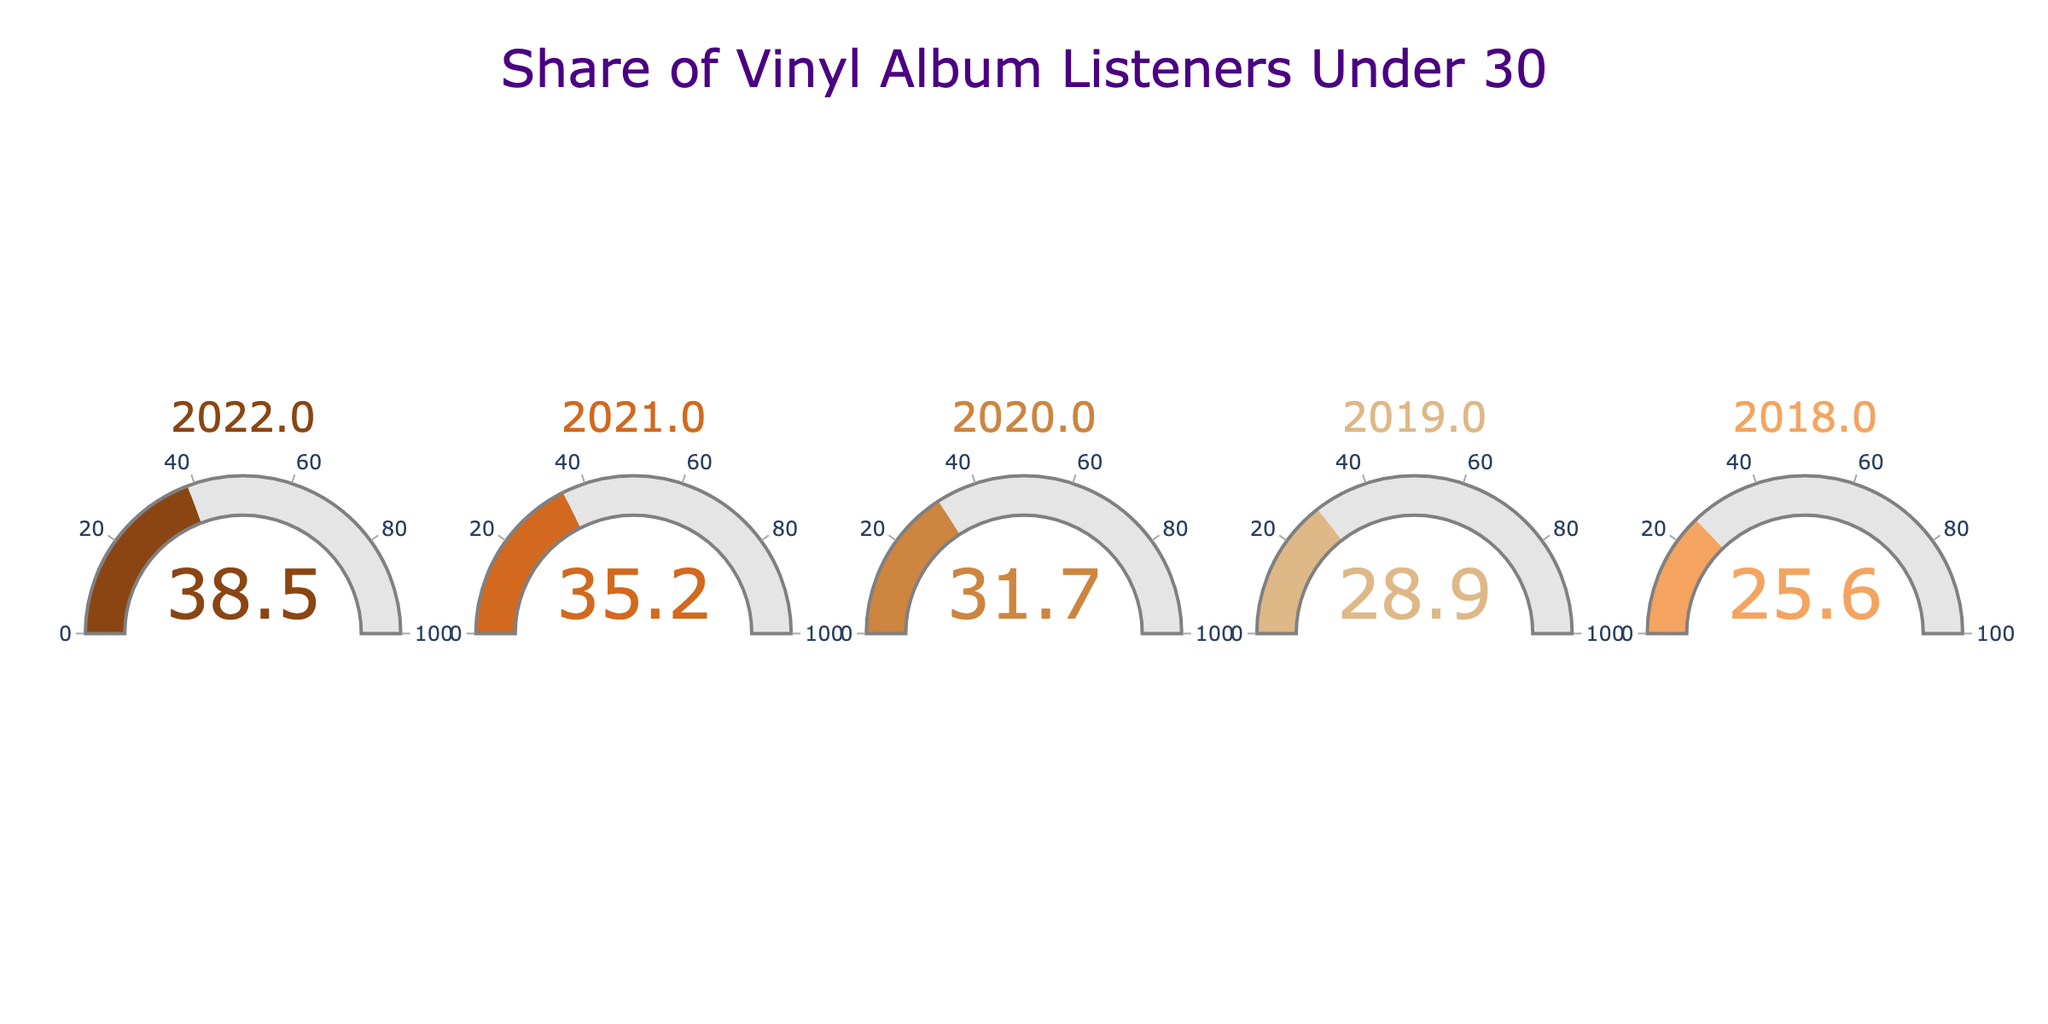What is the share of vinyl album listeners under 30 years old in 2022? The gauge chart for the year 2022 indicates a value close to 38.5%, which represents the share of vinyl album listeners under 30 years old in 2022.
Answer: 38.5% What is the overall trend in the share of vinyl album listeners under 30 years old from 2018 to 2022? Observing the values from the gauge charts for each year, there is a clear increasing trend in the share of vinyl album listeners under 30 years old, starting from 25.6% in 2018 and reaching 38.5% in 2022.
Answer: Increasing Which year shows the largest increase in the share of vinyl album listeners under 30 years old compared to the previous year? By comparing the year-over-year increases: 2019-2018 (28.9%-25.6%=3.3%), 2020-2019 (31.7%-28.9%=2.8%), 2021-2020 (35.2%-31.7%=3.5%), and 2022-2021 (38.5%-35.2%=3.3%), the largest increase is seen in 2021 compared to 2020 with an increase of 3.5%.
Answer: 2021 What is the average share of vinyl listeners under 30 years old over the five years displayed? To find the average, sum the values for each year (25.6 + 28.9 + 31.7 + 35.2 + 38.5) = 159.9, then divide by the number of years (5). The average share is 159.9 / 5 = 31.98%.
Answer: 31.98% How does the share in 2020 compare to the share in 2018? The share of vinyl listeners under 30 years in 2020 is 31.7%, while in 2018 it is 25.6%. The difference is 31.7% - 25.6% = 6.1%, indicating that the share increased by 6.1 percentage points.
Answer: Increased by 6.1% Which year had the lowest share of vinyl album listeners under 30 years old? From examining each gauge chart, the lowest share is in the year 2018, with a value of 25.6%.
Answer: 2018 What is the total increase in the share of vinyl listeners under 30 years old from 2018 to 2022? Subtract the 2018 share from the 2022 share: 38.5% - 25.6% = 12.9%. Thus, the total increase over the period is 12.9 percentage points.
Answer: 12.9% How much more is the gauge chart value for 2021 than the value for 2019? The value for 2021 is 35.2%, and for 2019 it is 28.9%. The difference is 35.2% - 28.9% = 6.3%, indicating that the share was 6.3 percentage points higher in 2021 than in 2019.
Answer: 6.3% 